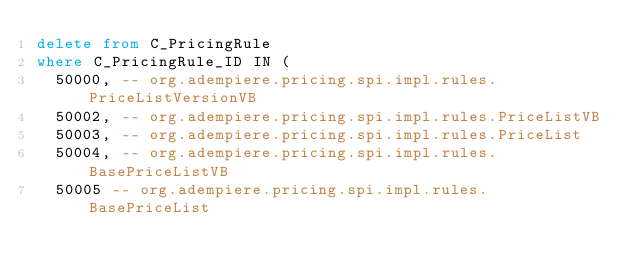Convert code to text. <code><loc_0><loc_0><loc_500><loc_500><_SQL_>delete from C_PricingRule
where C_PricingRule_ID IN (
	50000, -- org.adempiere.pricing.spi.impl.rules.PriceListVersionVB
	50002, -- org.adempiere.pricing.spi.impl.rules.PriceListVB
	50003, -- org.adempiere.pricing.spi.impl.rules.PriceList
	50004, -- org.adempiere.pricing.spi.impl.rules.BasePriceListVB
	50005 -- org.adempiere.pricing.spi.impl.rules.BasePriceList</code> 